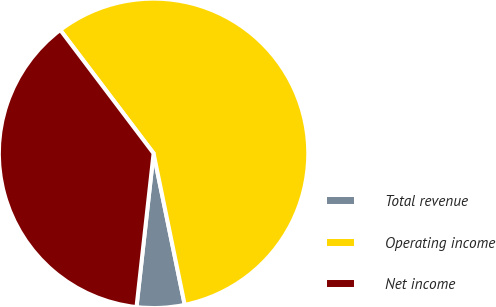<chart> <loc_0><loc_0><loc_500><loc_500><pie_chart><fcel>Total revenue<fcel>Operating income<fcel>Net income<nl><fcel>4.99%<fcel>57.08%<fcel>37.94%<nl></chart> 